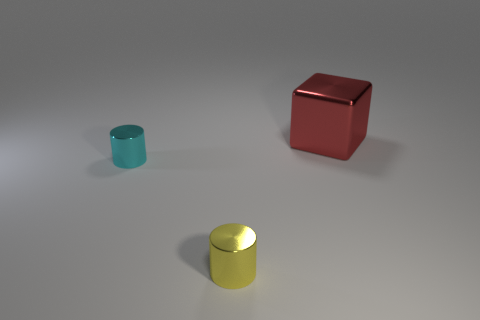Add 1 large red shiny cubes. How many objects exist? 4 Subtract all cubes. How many objects are left? 2 Add 3 tiny shiny objects. How many tiny shiny objects exist? 5 Subtract 0 brown blocks. How many objects are left? 3 Subtract all red shiny cylinders. Subtract all cylinders. How many objects are left? 1 Add 2 small metallic things. How many small metallic things are left? 4 